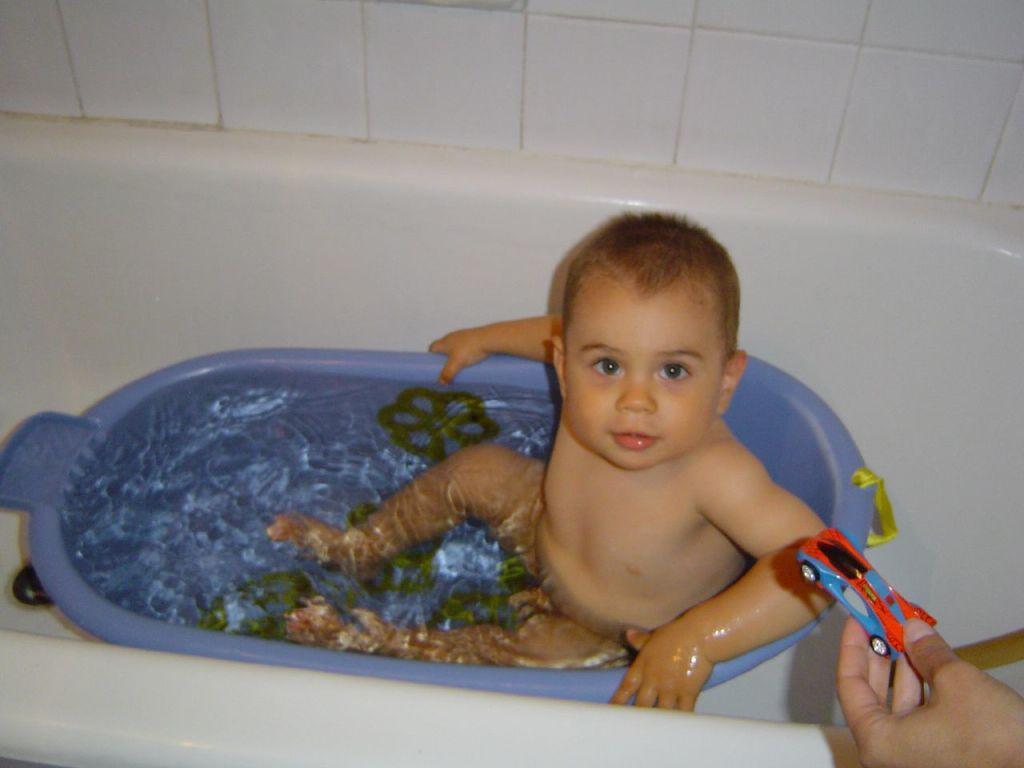In one or two sentences, can you explain what this image depicts? A little cute boy is in the bathtub, in the right side it is a car toy is holding by a human. The tub is in blue color. 